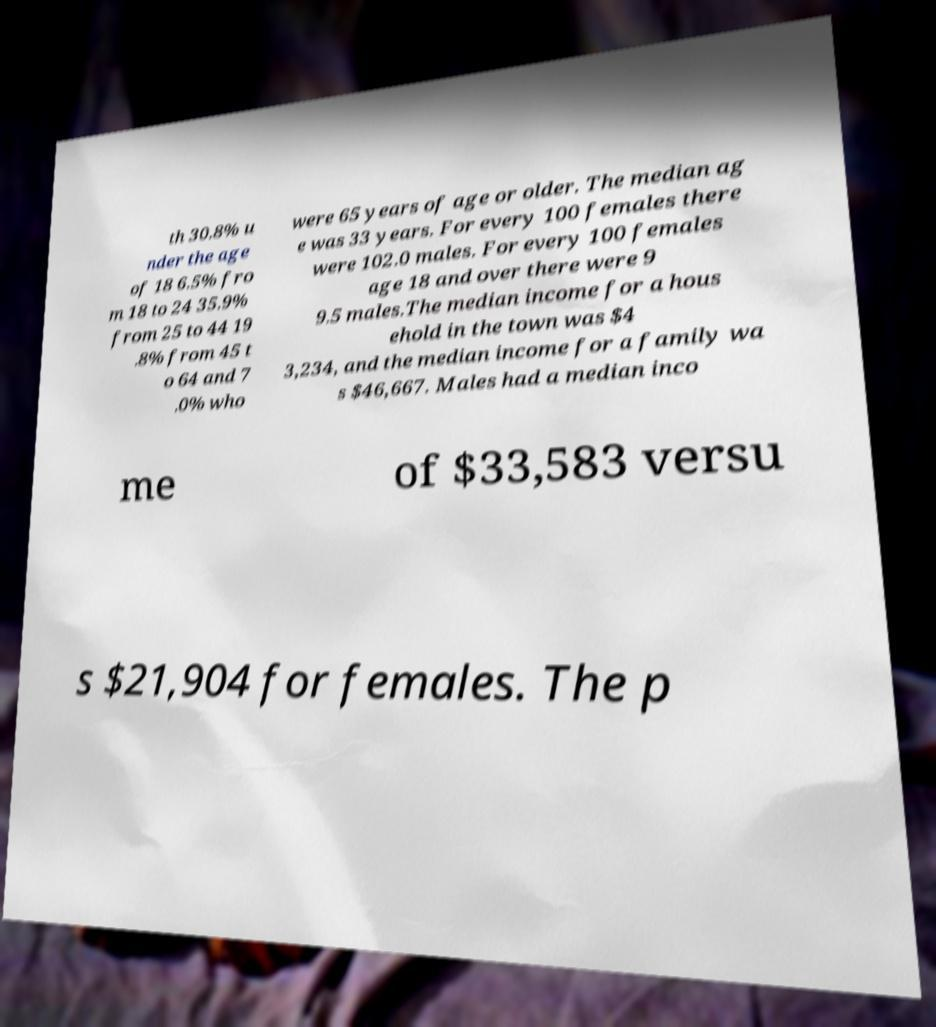I need the written content from this picture converted into text. Can you do that? th 30.8% u nder the age of 18 6.5% fro m 18 to 24 35.9% from 25 to 44 19 .8% from 45 t o 64 and 7 .0% who were 65 years of age or older. The median ag e was 33 years. For every 100 females there were 102.0 males. For every 100 females age 18 and over there were 9 9.5 males.The median income for a hous ehold in the town was $4 3,234, and the median income for a family wa s $46,667. Males had a median inco me of $33,583 versu s $21,904 for females. The p 